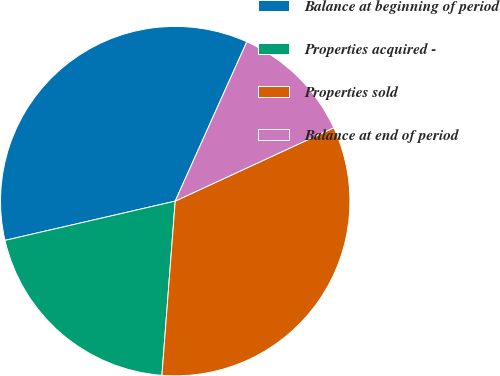Convert chart to OTSL. <chart><loc_0><loc_0><loc_500><loc_500><pie_chart><fcel>Balance at beginning of period<fcel>Properties acquired -<fcel>Properties sold<fcel>Balance at end of period<nl><fcel>35.33%<fcel>20.18%<fcel>33.11%<fcel>11.38%<nl></chart> 